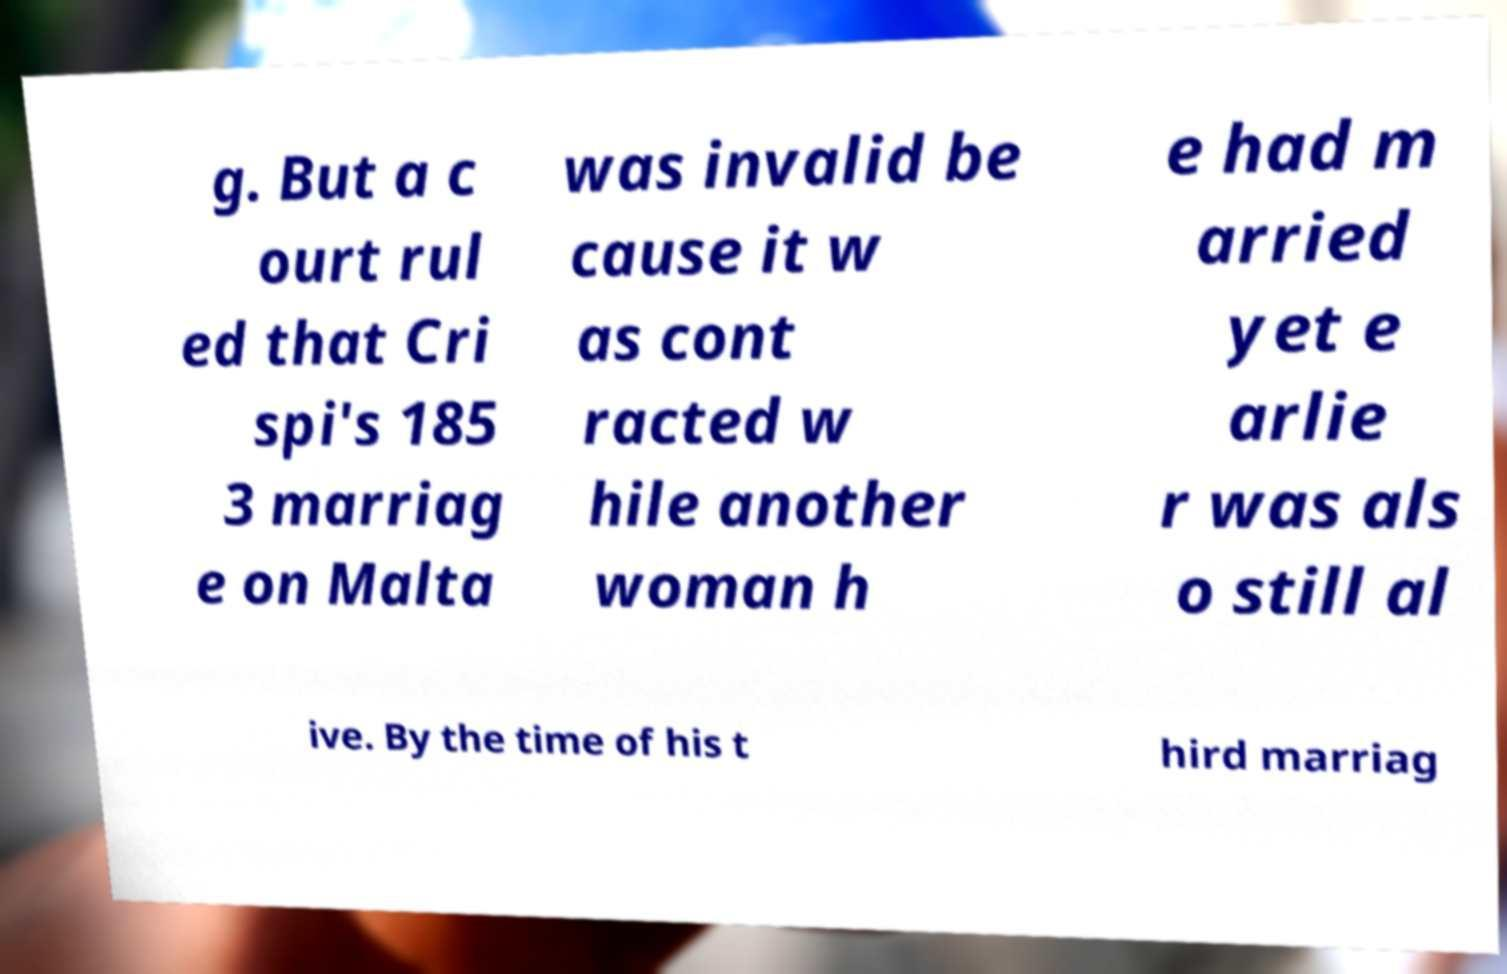There's text embedded in this image that I need extracted. Can you transcribe it verbatim? g. But a c ourt rul ed that Cri spi's 185 3 marriag e on Malta was invalid be cause it w as cont racted w hile another woman h e had m arried yet e arlie r was als o still al ive. By the time of his t hird marriag 